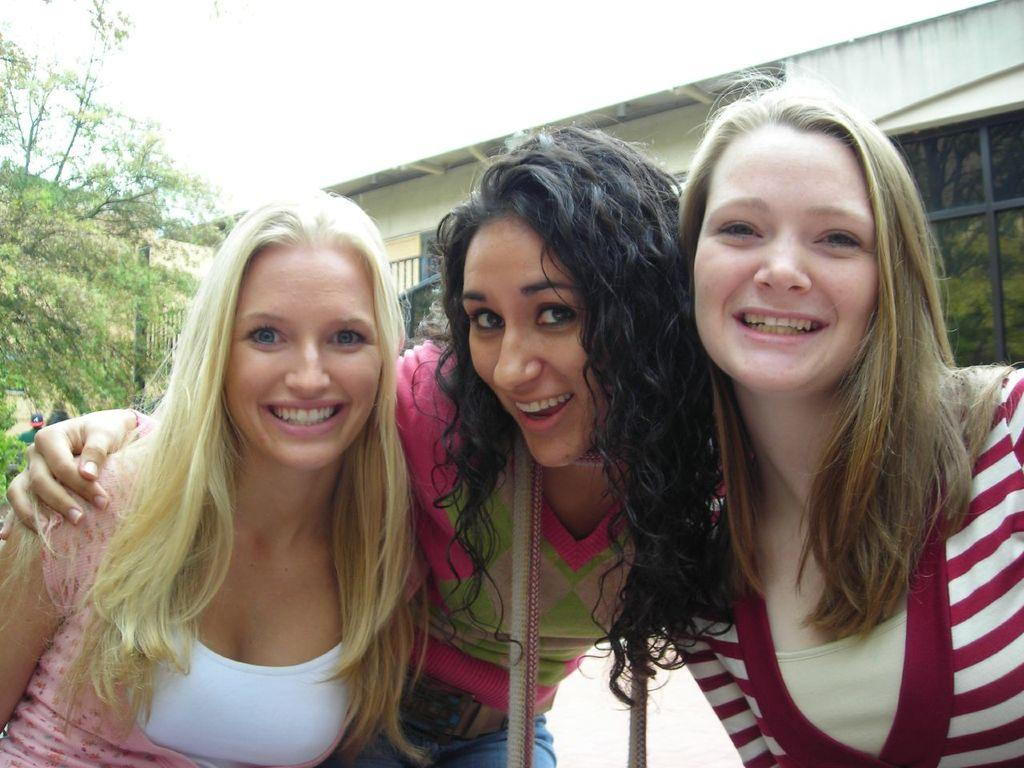How many women are in the image? There are three women in the image. What are the women doing in the image? The women are holding each other. What can be seen in the background of the image? There is a building and a tree in the background of the image. What type of brush is the woman on the left using in the image? There is no brush present in the image; the women are holding each other. 